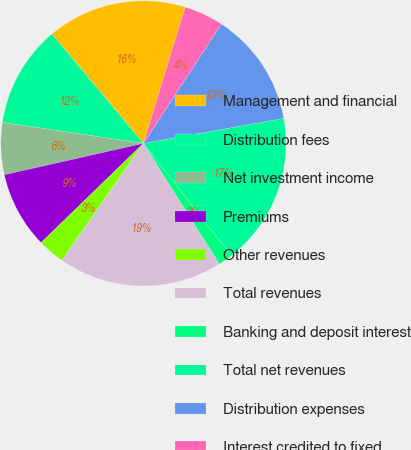Convert chart to OTSL. <chart><loc_0><loc_0><loc_500><loc_500><pie_chart><fcel>Management and financial<fcel>Distribution fees<fcel>Net investment income<fcel>Premiums<fcel>Other revenues<fcel>Total revenues<fcel>Banking and deposit interest<fcel>Total net revenues<fcel>Distribution expenses<fcel>Interest credited to fixed<nl><fcel>15.82%<fcel>11.56%<fcel>5.89%<fcel>8.72%<fcel>3.05%<fcel>18.65%<fcel>1.63%<fcel>17.23%<fcel>12.98%<fcel>4.47%<nl></chart> 